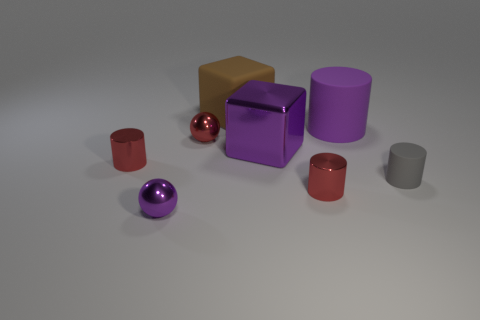There is a big purple thing that is on the right side of the cube that is in front of the big matte object that is to the right of the large purple metal block; what is its shape?
Your response must be concise. Cylinder. There is a gray cylinder; does it have the same size as the cylinder that is left of the large metal thing?
Keep it short and to the point. Yes. There is a metal thing that is left of the shiny block and right of the tiny purple thing; what shape is it?
Your answer should be very brief. Sphere. What number of big objects are either red balls or brown objects?
Provide a succinct answer. 1. Are there the same number of red things that are right of the big metallic cube and small metal objects to the right of the rubber cube?
Your response must be concise. Yes. How many other things are the same color as the big cylinder?
Your response must be concise. 2. Is the number of large shiny blocks to the left of the large matte block the same as the number of big purple metal cubes?
Give a very brief answer. No. Is the purple matte thing the same size as the gray object?
Provide a short and direct response. No. The red thing that is in front of the red sphere and to the left of the big metallic block is made of what material?
Offer a terse response. Metal. What number of purple things are the same shape as the large brown object?
Make the answer very short. 1. 